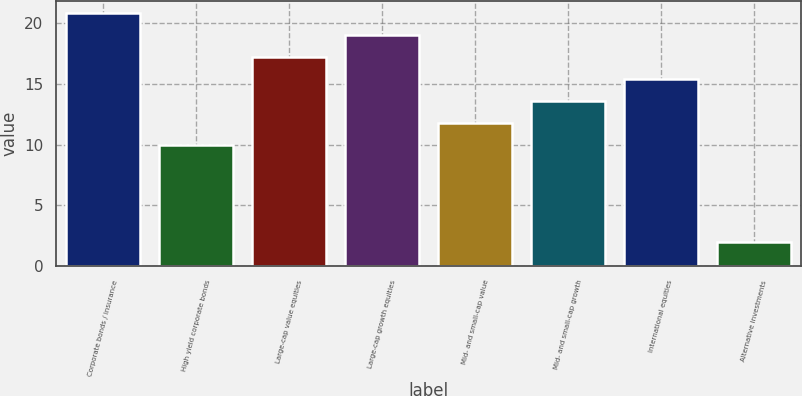Convert chart to OTSL. <chart><loc_0><loc_0><loc_500><loc_500><bar_chart><fcel>Corporate bonds / insurance<fcel>High yield corporate bonds<fcel>Large-cap value equities<fcel>Large-cap growth equities<fcel>Mid- and small-cap value<fcel>Mid- and small-cap growth<fcel>International equities<fcel>Alternative investments<nl><fcel>20.8<fcel>10<fcel>17.2<fcel>19<fcel>11.8<fcel>13.6<fcel>15.4<fcel>2<nl></chart> 